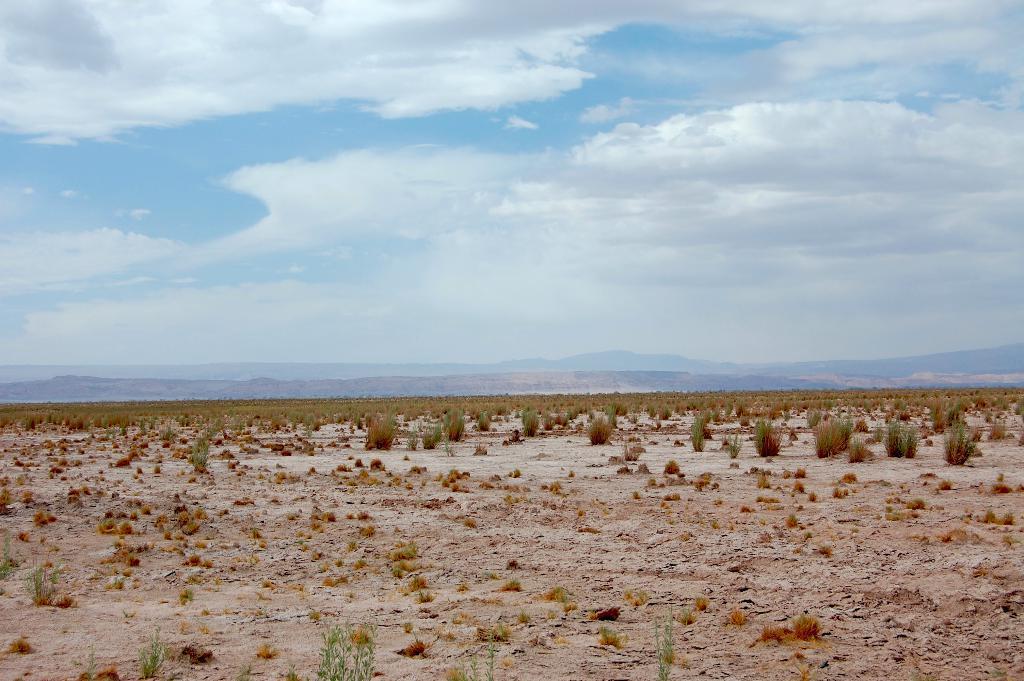How would you summarize this image in a sentence or two? In this image, we can see plants and grass. In the background, we can see the hills and cloudy sky. 